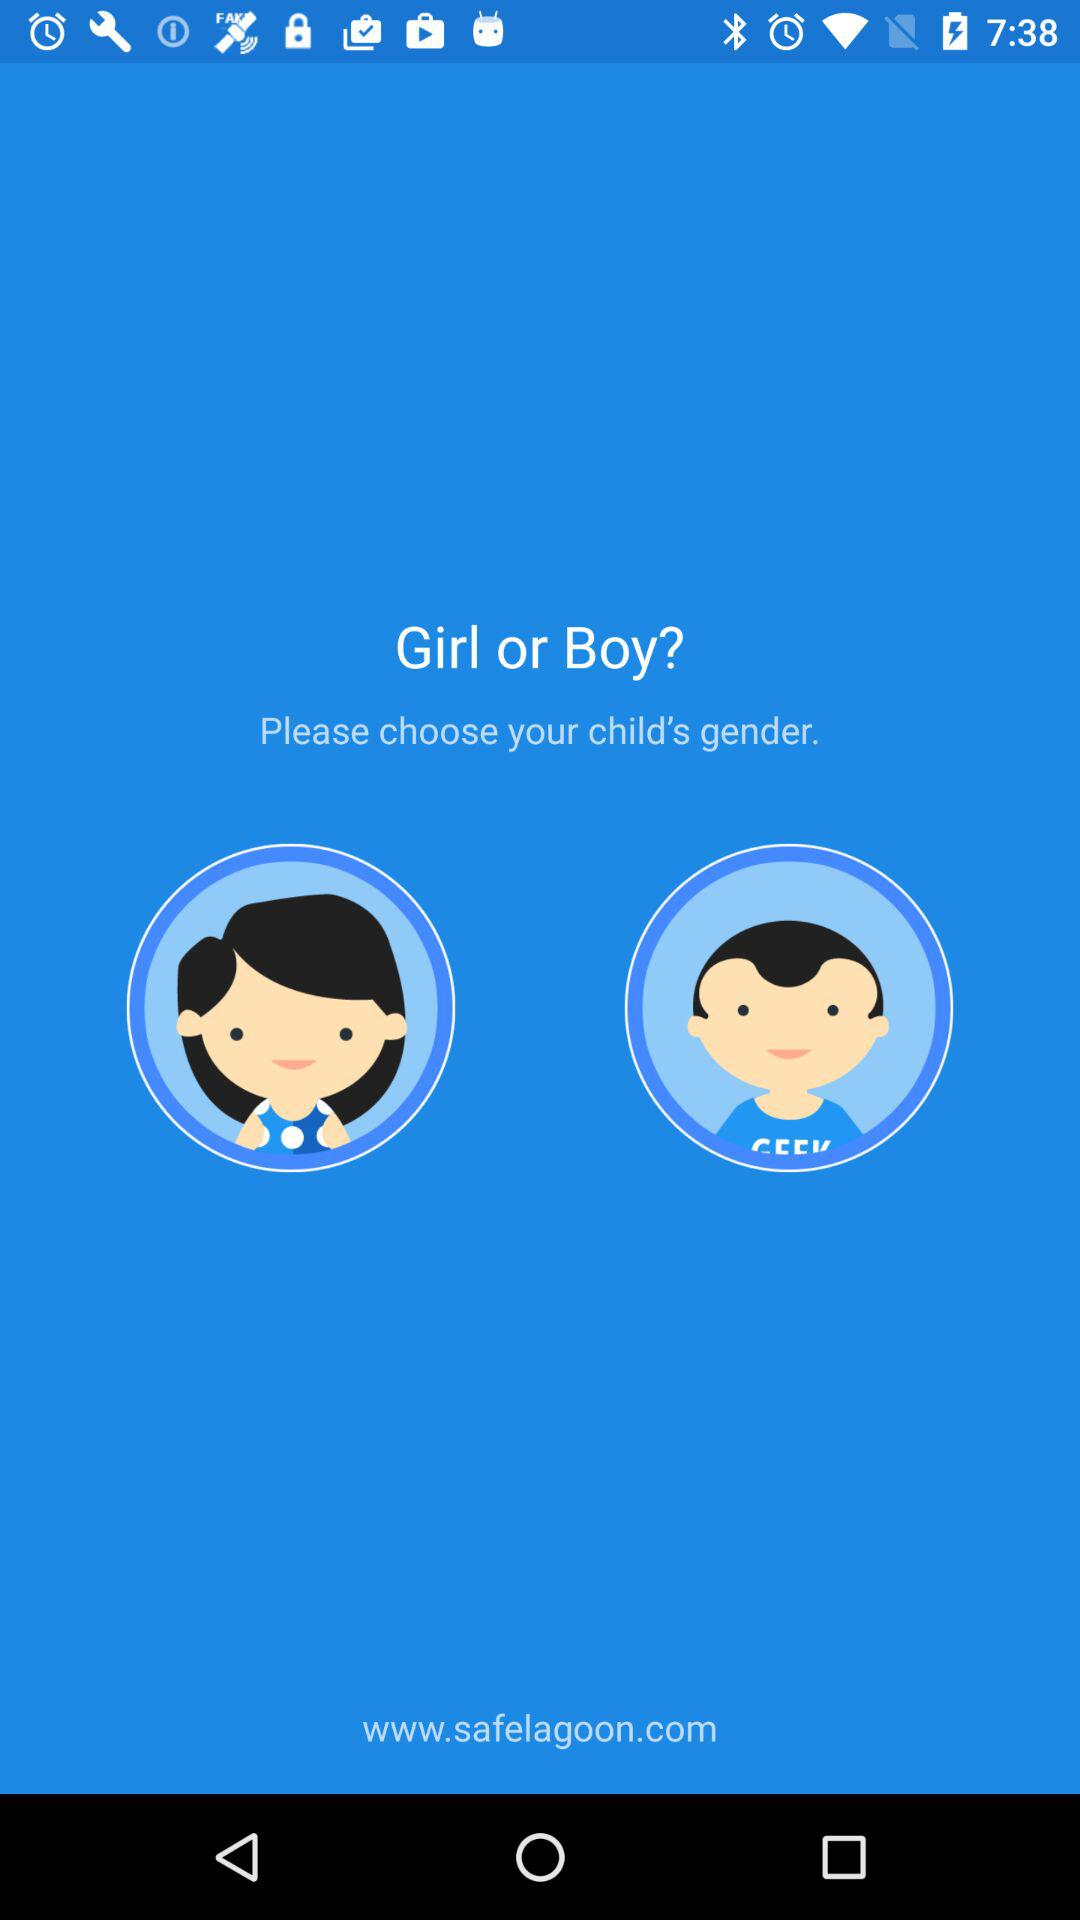What is the web address? The web address is www.safelagoon.com. 